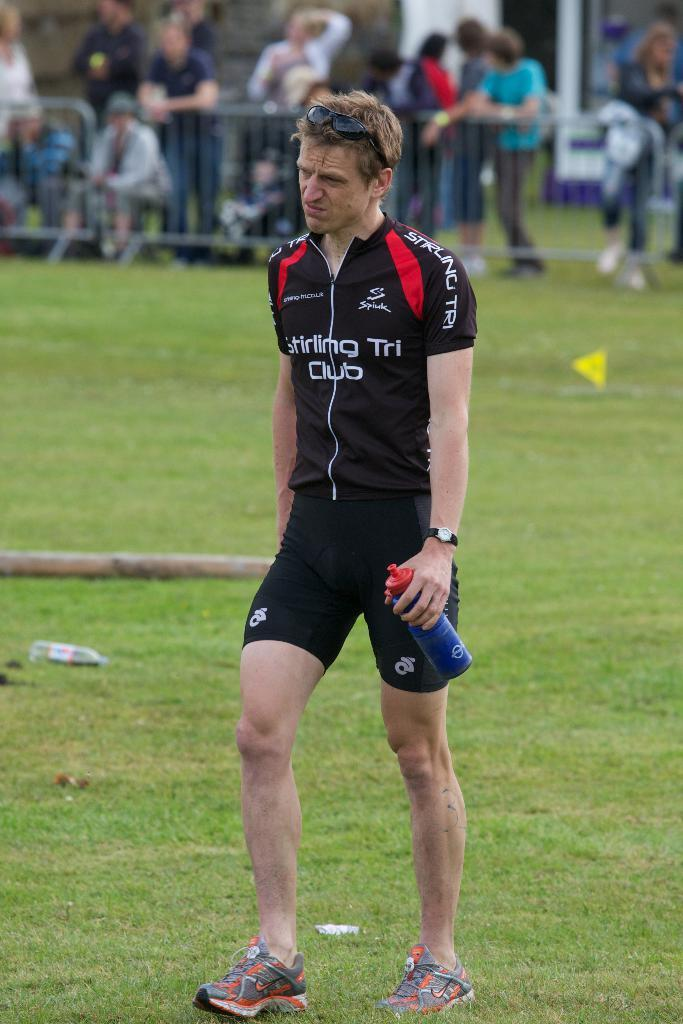<image>
Share a concise interpretation of the image provided. Man holding a water bottle while wearing a shirt that says "Stirling Tri Club". 